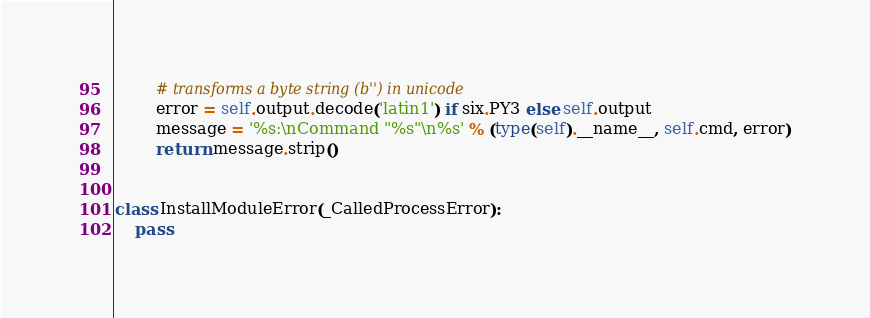Convert code to text. <code><loc_0><loc_0><loc_500><loc_500><_Python_>        # transforms a byte string (b'') in unicode
        error = self.output.decode('latin1') if six.PY3 else self.output
        message = '%s:\nCommand "%s"\n%s' % (type(self).__name__, self.cmd, error)
        return message.strip()


class InstallModuleError(_CalledProcessError):
    pass

</code> 